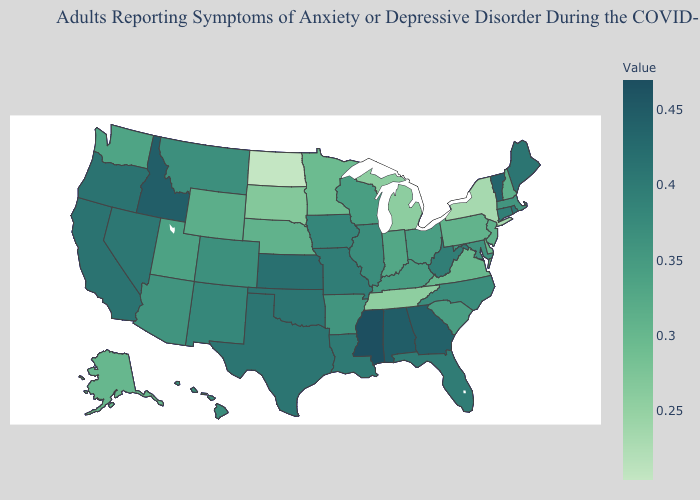Does Iowa have a lower value than Mississippi?
Short answer required. Yes. Does North Carolina have a higher value than Florida?
Keep it brief. No. Among the states that border Wisconsin , does Michigan have the highest value?
Write a very short answer. No. Which states have the highest value in the USA?
Concise answer only. Mississippi. Does Mississippi have the highest value in the USA?
Give a very brief answer. Yes. Is the legend a continuous bar?
Write a very short answer. Yes. Among the states that border Pennsylvania , does New York have the lowest value?
Quick response, please. Yes. Which states have the lowest value in the Northeast?
Quick response, please. New York. 